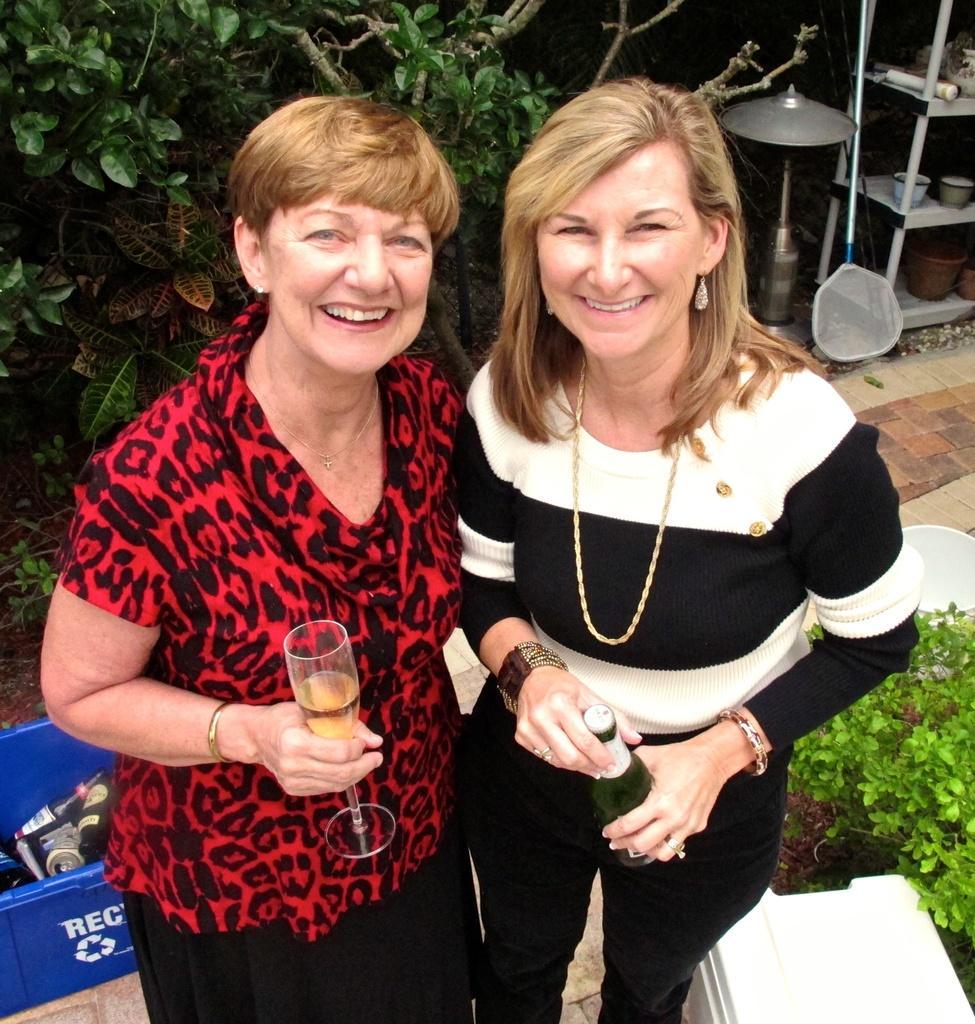Could you give a brief overview of what you see in this image? In the image we can see two women wearing clothes, neck chains, bracelets, earrings and they are smiling. The left side woman is holding a wine glass and the right side woman is holding the bottle in hand. Here we can see plastic container, in it we can see the bottles. There is a plant, leaves and other things. 